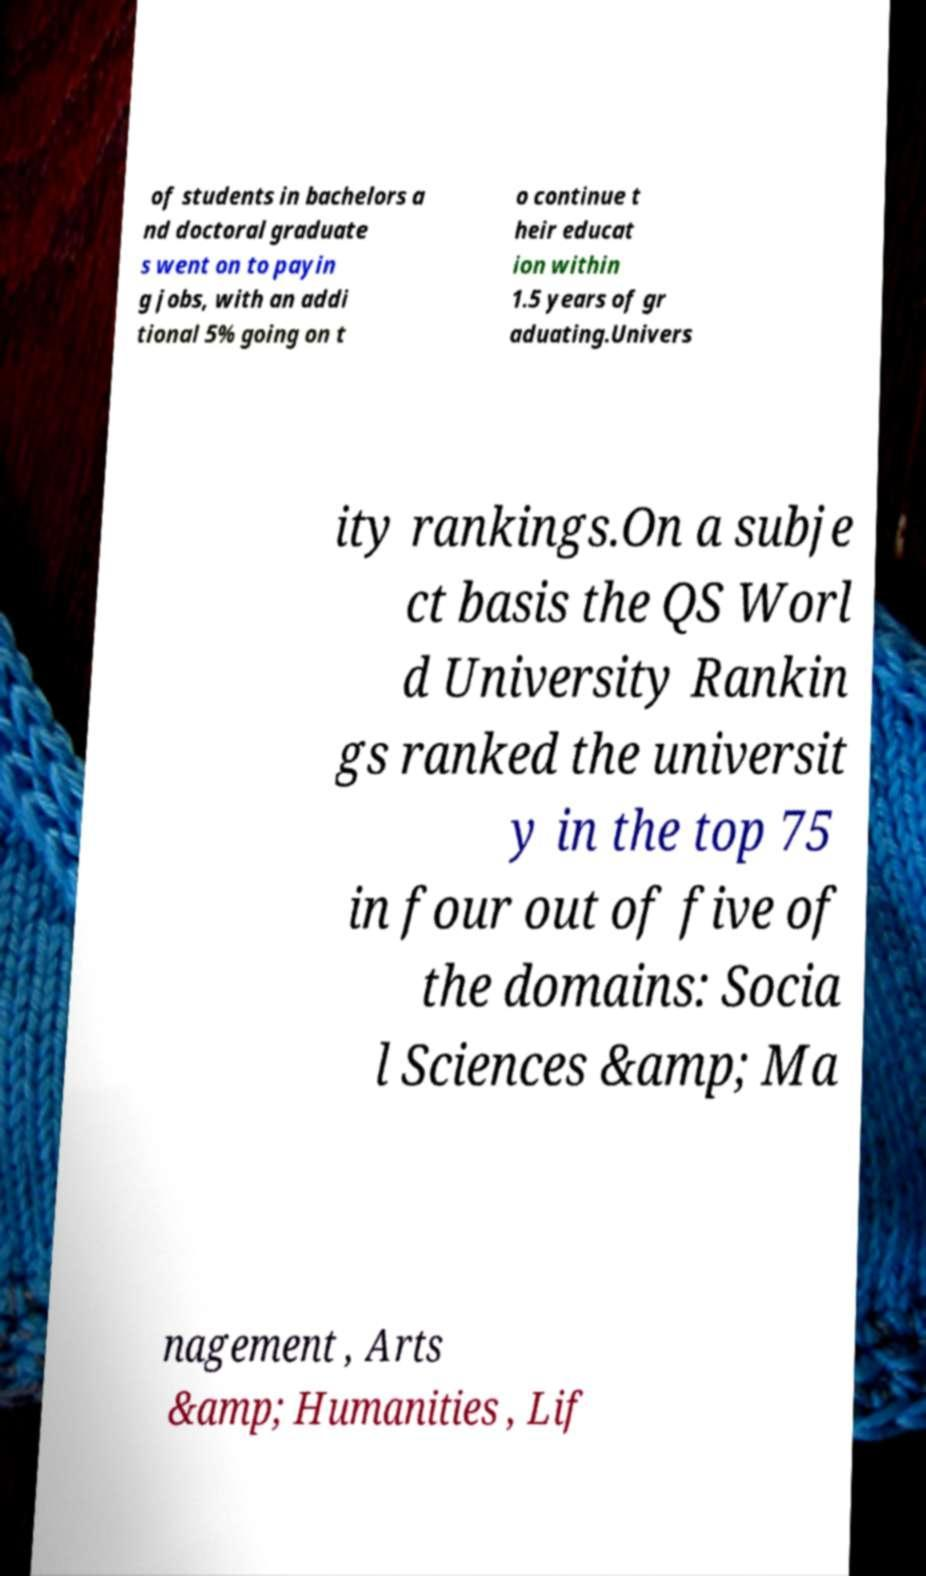Can you read and provide the text displayed in the image?This photo seems to have some interesting text. Can you extract and type it out for me? of students in bachelors a nd doctoral graduate s went on to payin g jobs, with an addi tional 5% going on t o continue t heir educat ion within 1.5 years of gr aduating.Univers ity rankings.On a subje ct basis the QS Worl d University Rankin gs ranked the universit y in the top 75 in four out of five of the domains: Socia l Sciences &amp; Ma nagement , Arts &amp; Humanities , Lif 